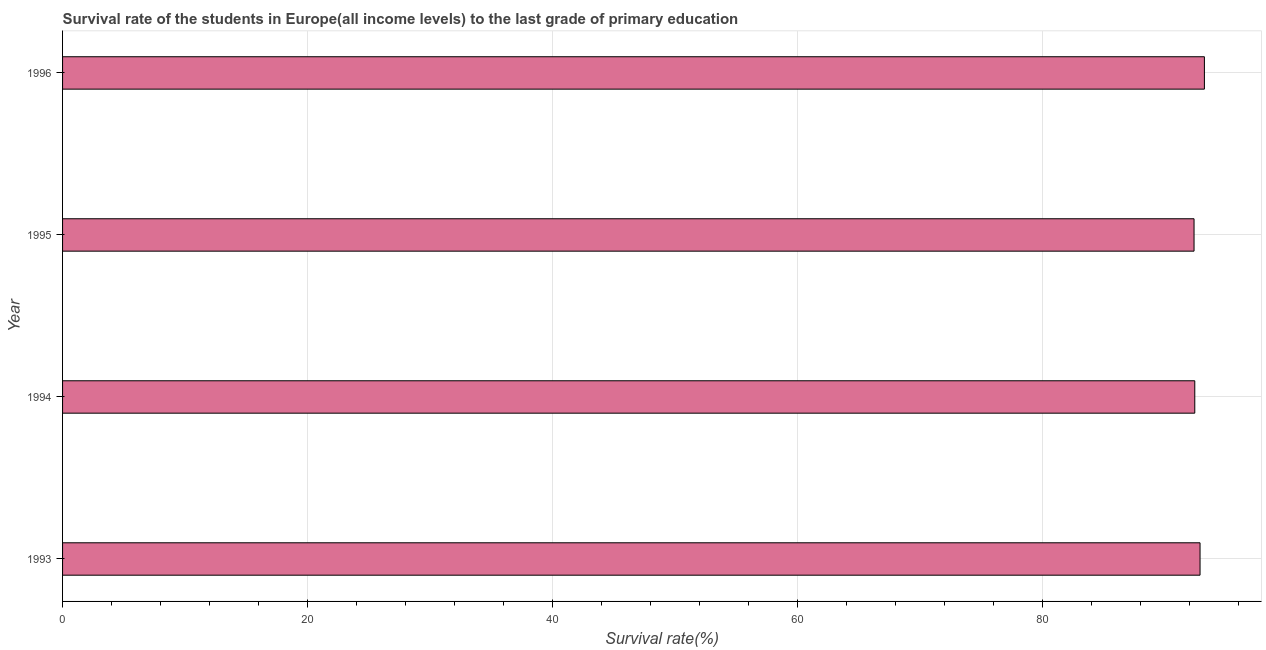Does the graph contain grids?
Offer a terse response. Yes. What is the title of the graph?
Keep it short and to the point. Survival rate of the students in Europe(all income levels) to the last grade of primary education. What is the label or title of the X-axis?
Your response must be concise. Survival rate(%). What is the label or title of the Y-axis?
Your answer should be compact. Year. What is the survival rate in primary education in 1994?
Offer a very short reply. 92.46. Across all years, what is the maximum survival rate in primary education?
Provide a short and direct response. 93.25. Across all years, what is the minimum survival rate in primary education?
Ensure brevity in your answer.  92.4. In which year was the survival rate in primary education maximum?
Your answer should be compact. 1996. What is the sum of the survival rate in primary education?
Your answer should be compact. 371. What is the difference between the survival rate in primary education in 1993 and 1995?
Ensure brevity in your answer.  0.49. What is the average survival rate in primary education per year?
Your response must be concise. 92.75. What is the median survival rate in primary education?
Ensure brevity in your answer.  92.68. In how many years, is the survival rate in primary education greater than 52 %?
Your response must be concise. 4. Is the survival rate in primary education in 1993 less than that in 1995?
Offer a very short reply. No. What is the difference between the highest and the second highest survival rate in primary education?
Provide a succinct answer. 0.36. What is the difference between the highest and the lowest survival rate in primary education?
Keep it short and to the point. 0.85. How many bars are there?
Ensure brevity in your answer.  4. What is the difference between two consecutive major ticks on the X-axis?
Your answer should be very brief. 20. Are the values on the major ticks of X-axis written in scientific E-notation?
Make the answer very short. No. What is the Survival rate(%) of 1993?
Offer a terse response. 92.89. What is the Survival rate(%) of 1994?
Offer a very short reply. 92.46. What is the Survival rate(%) of 1995?
Your response must be concise. 92.4. What is the Survival rate(%) in 1996?
Ensure brevity in your answer.  93.25. What is the difference between the Survival rate(%) in 1993 and 1994?
Your answer should be compact. 0.43. What is the difference between the Survival rate(%) in 1993 and 1995?
Give a very brief answer. 0.49. What is the difference between the Survival rate(%) in 1993 and 1996?
Ensure brevity in your answer.  -0.36. What is the difference between the Survival rate(%) in 1994 and 1995?
Offer a very short reply. 0.06. What is the difference between the Survival rate(%) in 1994 and 1996?
Your answer should be very brief. -0.79. What is the difference between the Survival rate(%) in 1995 and 1996?
Your answer should be very brief. -0.85. What is the ratio of the Survival rate(%) in 1993 to that in 1994?
Make the answer very short. 1. What is the ratio of the Survival rate(%) in 1994 to that in 1995?
Provide a succinct answer. 1. What is the ratio of the Survival rate(%) in 1994 to that in 1996?
Make the answer very short. 0.99. 